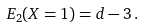<formula> <loc_0><loc_0><loc_500><loc_500>E _ { 2 } ( X = 1 ) = d - 3 \, .</formula> 